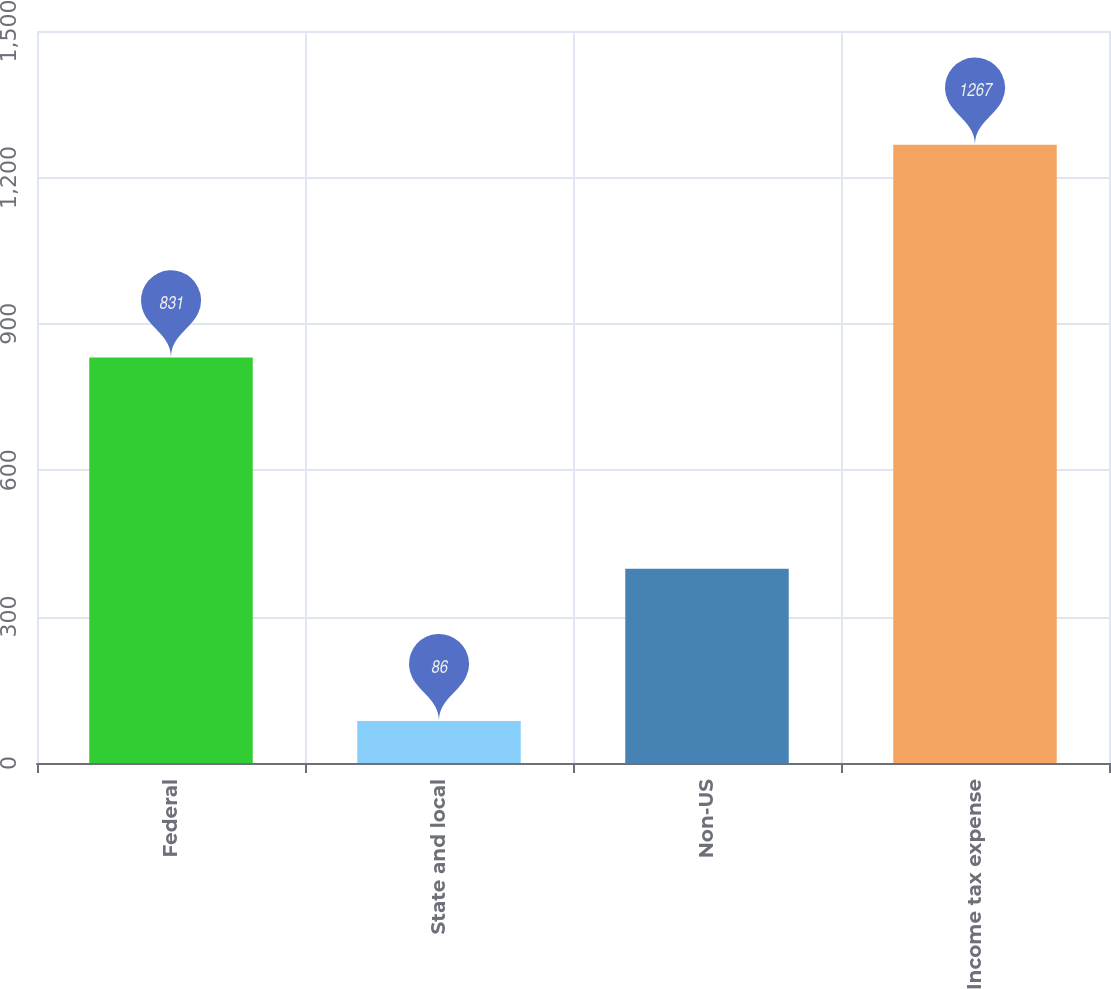<chart> <loc_0><loc_0><loc_500><loc_500><bar_chart><fcel>Federal<fcel>State and local<fcel>Non-US<fcel>Income tax expense<nl><fcel>831<fcel>86<fcel>398<fcel>1267<nl></chart> 